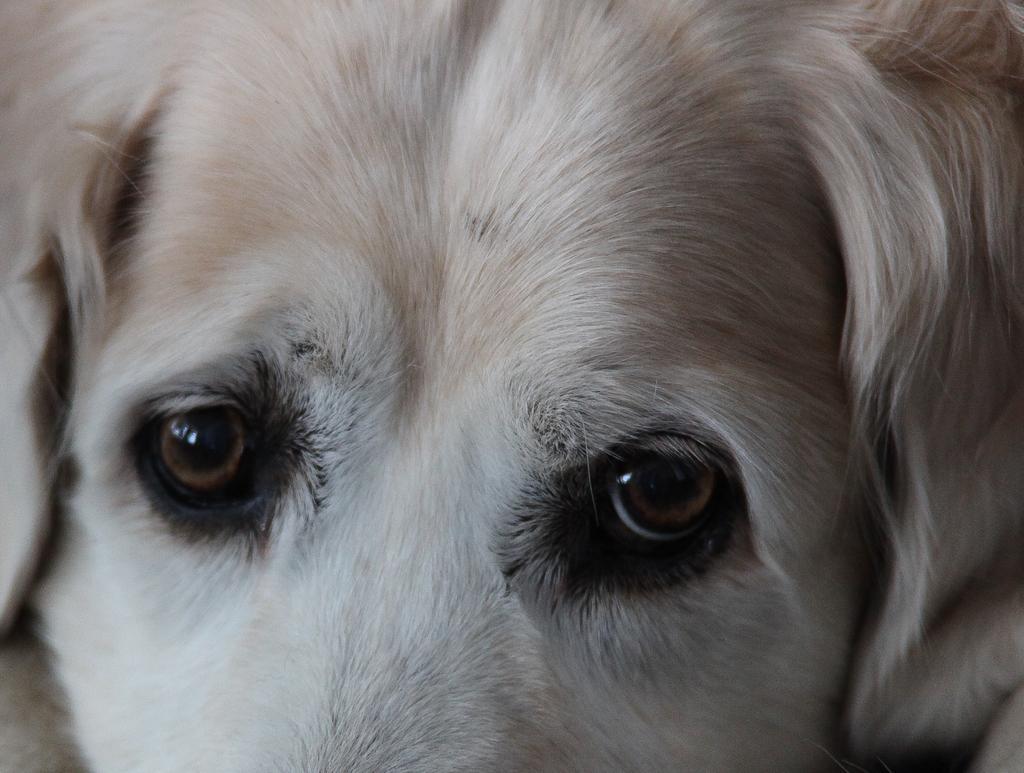Could you give a brief overview of what you see in this image? In this image there is an animal visible. 